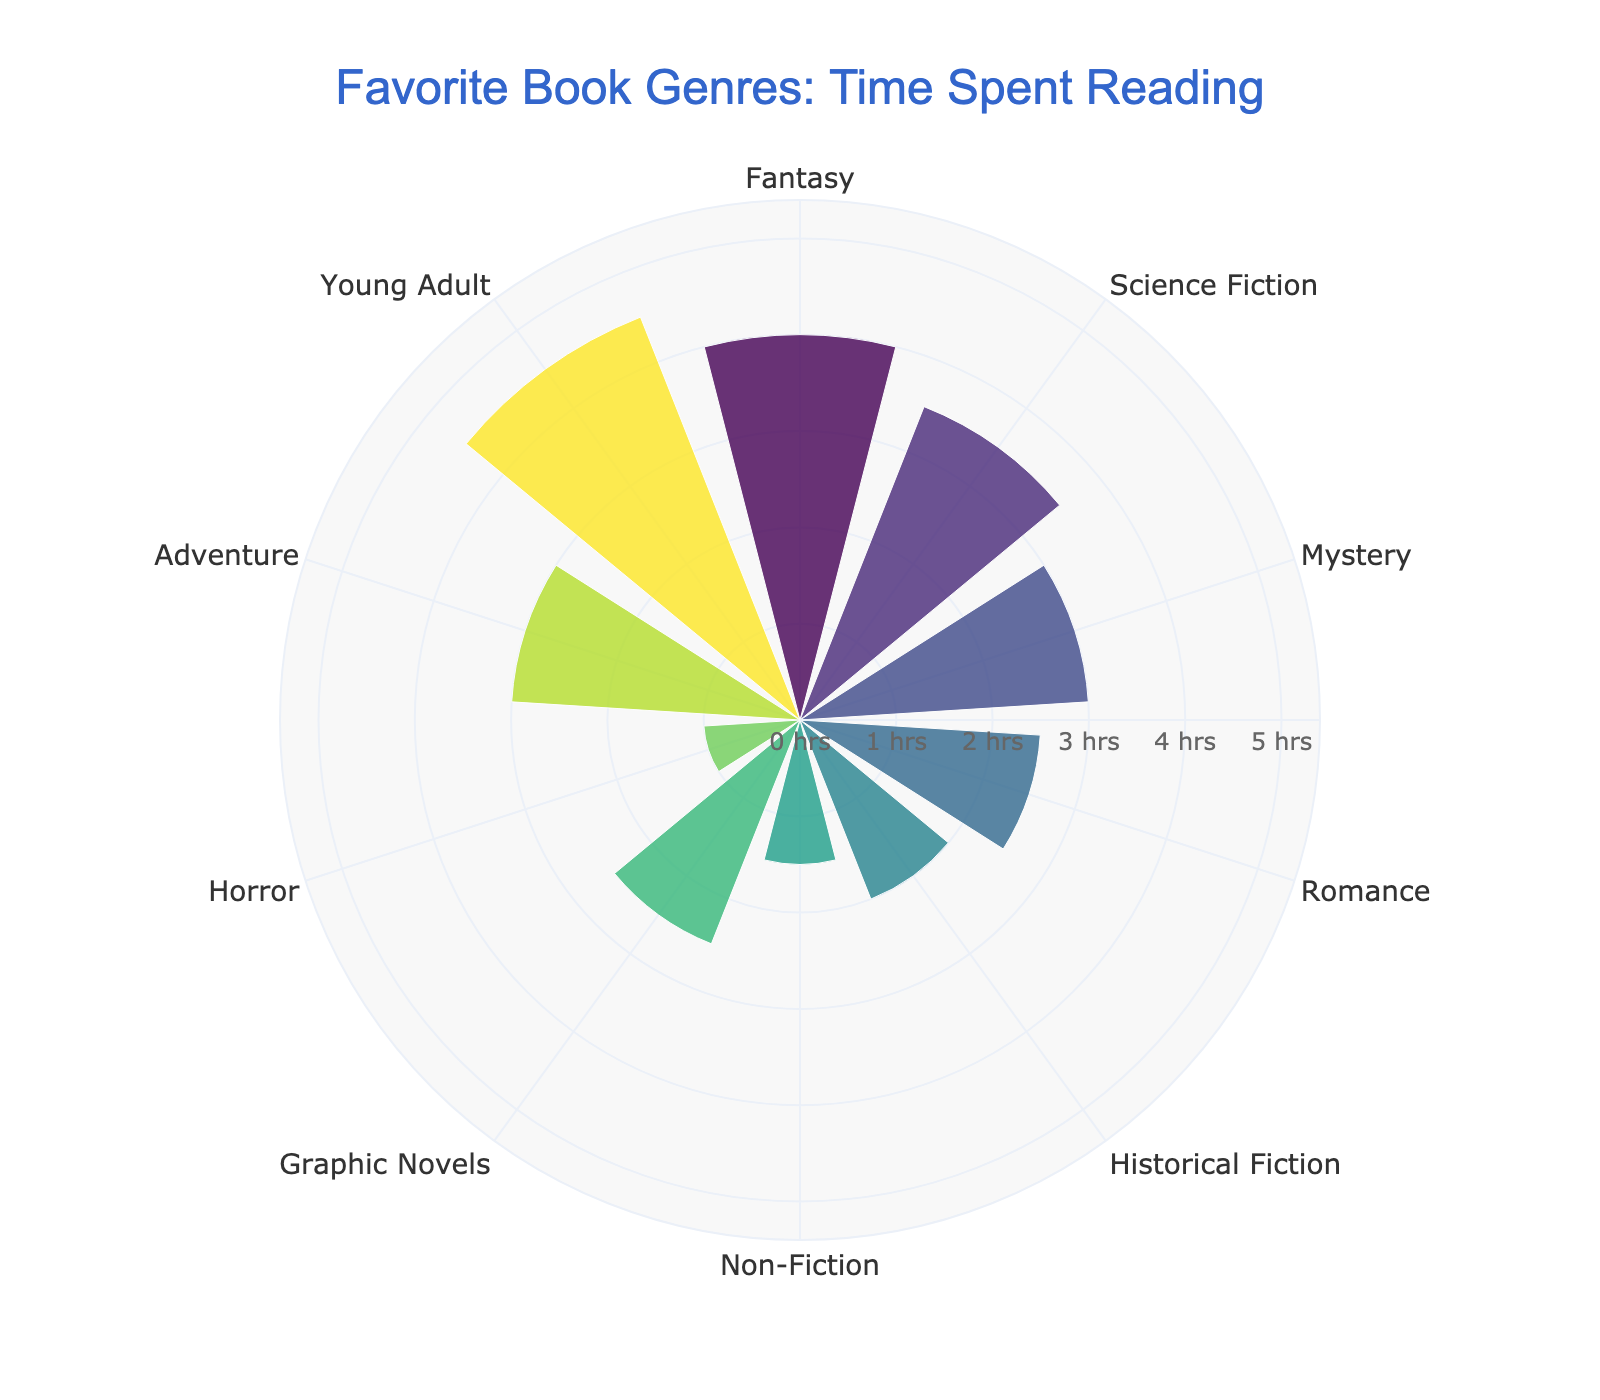What is the title of the rose chart? The title is located at the top of the chart and is the first piece of textual data visible.
Answer: Favorite Book Genres: Time Spent Reading Which genre has the highest average hours spent per week? Look at the length of each bar and find the one that extends the furthest from the center.
Answer: Young Adult How many genres show an average reading time of 2.5 hours per week? Find the bars labeled with the respective genres and check their length.
Answer: Two (Romance and Graphic Novels) Which genre has the lowest average reading time? Identify the shortest bar in the chart.
Answer: Horror What is the combined average reading time of Science Fiction and Adventure? Locate the bars for Science Fiction and Adventure, note their lengths, and add them together (3.5 + 3).
Answer: 6.5 hours Is the average reading time for Fantasy greater than Romance? Compare the lengths of the bars for Fantasy and Romance.
Answer: Yes Which genre has a 3 hours average reading time? Identify the bar whose length corresponds to 3 hours.
Answer: Mystery How many genres have an average reading time greater than 3 hours per week? Count the bars that extend beyond the 3-hour mark.
Answer: Four (Fantasy, Adventure, Young Adult, Science Fiction) If you sum the average reading times of Non-Fiction and Horror, is it equal to the average reading time of Young Adult? Add the time for Non-Fiction and Horror (1.5 + 1) and compare it with Young Adult (4.5).
Answer: No What is the range of average reading times represented in the chart? Identify the minimum and maximum average reading times and calculate the difference (4.5 - 1).
Answer: 3.5 hours 